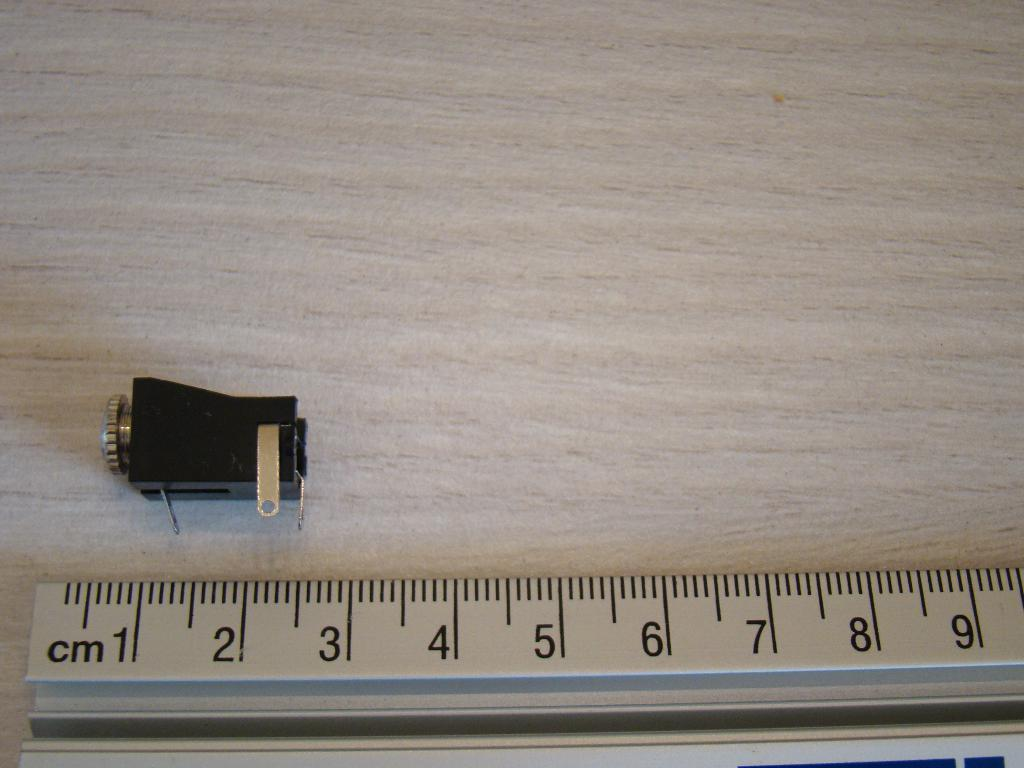<image>
Present a compact description of the photo's key features. ruler with cm and numbers wrote on it that measures items 